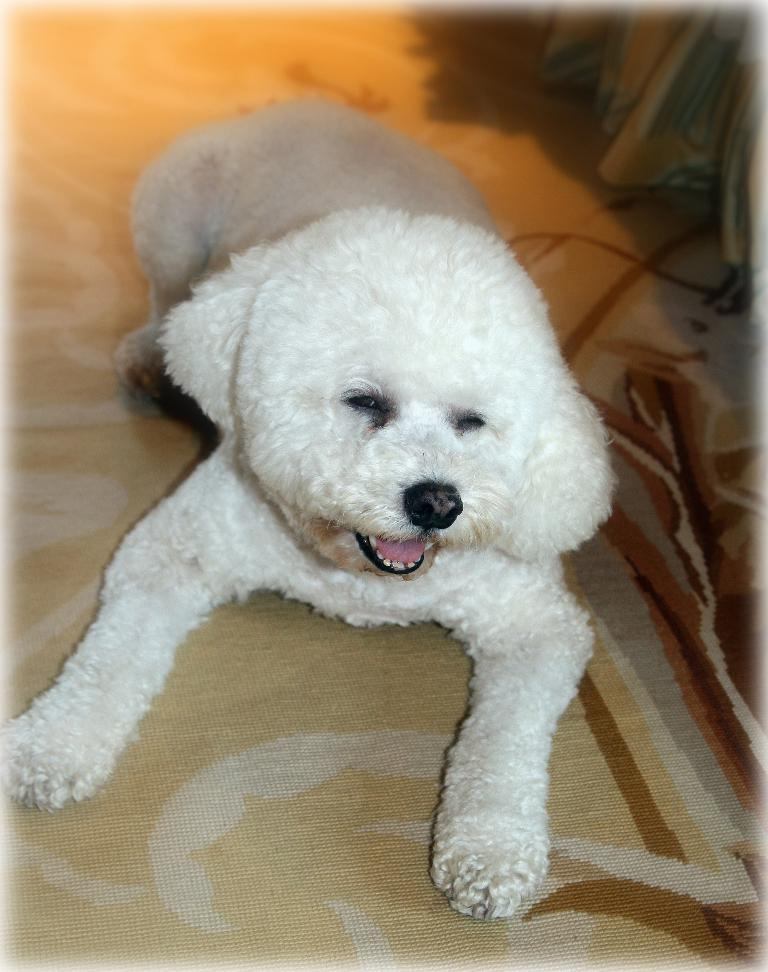What type of animal is present in the image? There is a white-colored dog in the image. Can you describe the appearance of the dog? The dog is white in color. What is the quality of the background in the image? The background of the image is blurry. What type of flame can be seen on the watch in the image? There is no watch or flame present in the image. What type of car is visible in the image? There is no car present in the image. 